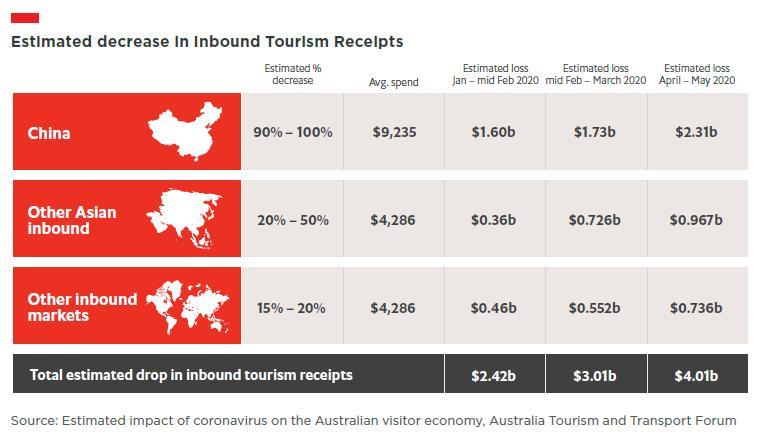What is the total estimated loss in inbound tourism receipts during April-May 2020 due to the impact of coronavirus?
Answer the question with a short phrase. $4.01b What is the average spend made in inbound tourism by China? $9,235 What is the estimated percentage decrease in inbound tourism receipts  in China due to the impact of coronavirus? 90%-100% What is the estimated loss in inbound tourism receipts during April- May 2020 in China due to the impact of coronavirus? $2.31b What is the estimated loss in inbound tourism receipts during Jan-Mid Feb 2020 in other inbound markets due to the impact of coronavirus? $0.46b What is the average spend made in inbound tourism by other inbound markets? $4,286 What is the estimated percentage decrease in inbound tourism receipts in other inbound markets due to the impact of coronavirus? 15%-20% What is the average spend made in inbound tourism by other Asian inbound markets? $4,286 